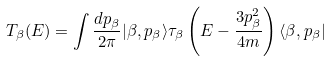<formula> <loc_0><loc_0><loc_500><loc_500>T _ { \beta } ( E ) = \int { \frac { d p _ { \beta } } { 2 \pi } | \beta , p _ { \beta } \rangle \tau _ { \beta } \left ( E - \frac { 3 p _ { \beta } ^ { 2 } } { 4 m } \right ) \langle \beta , p _ { \beta } | }</formula> 